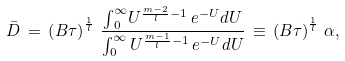<formula> <loc_0><loc_0><loc_500><loc_500>\bar { D } \, = \, \left ( B \tau \right ) ^ { \frac { 1 } { l } } \, \frac { { \int } _ { 0 } ^ { \infty } U ^ { \frac { m - 2 } { l } - 1 } \, { e } ^ { - U } { d U } } { \int _ { 0 } ^ { \infty } U ^ { \frac { m - 1 } { l } - 1 } \, { e } ^ { - U } { d U } } \, \equiv \, \left ( B \tau \right ) ^ { \frac { 1 } { l } } \, \alpha ,</formula> 